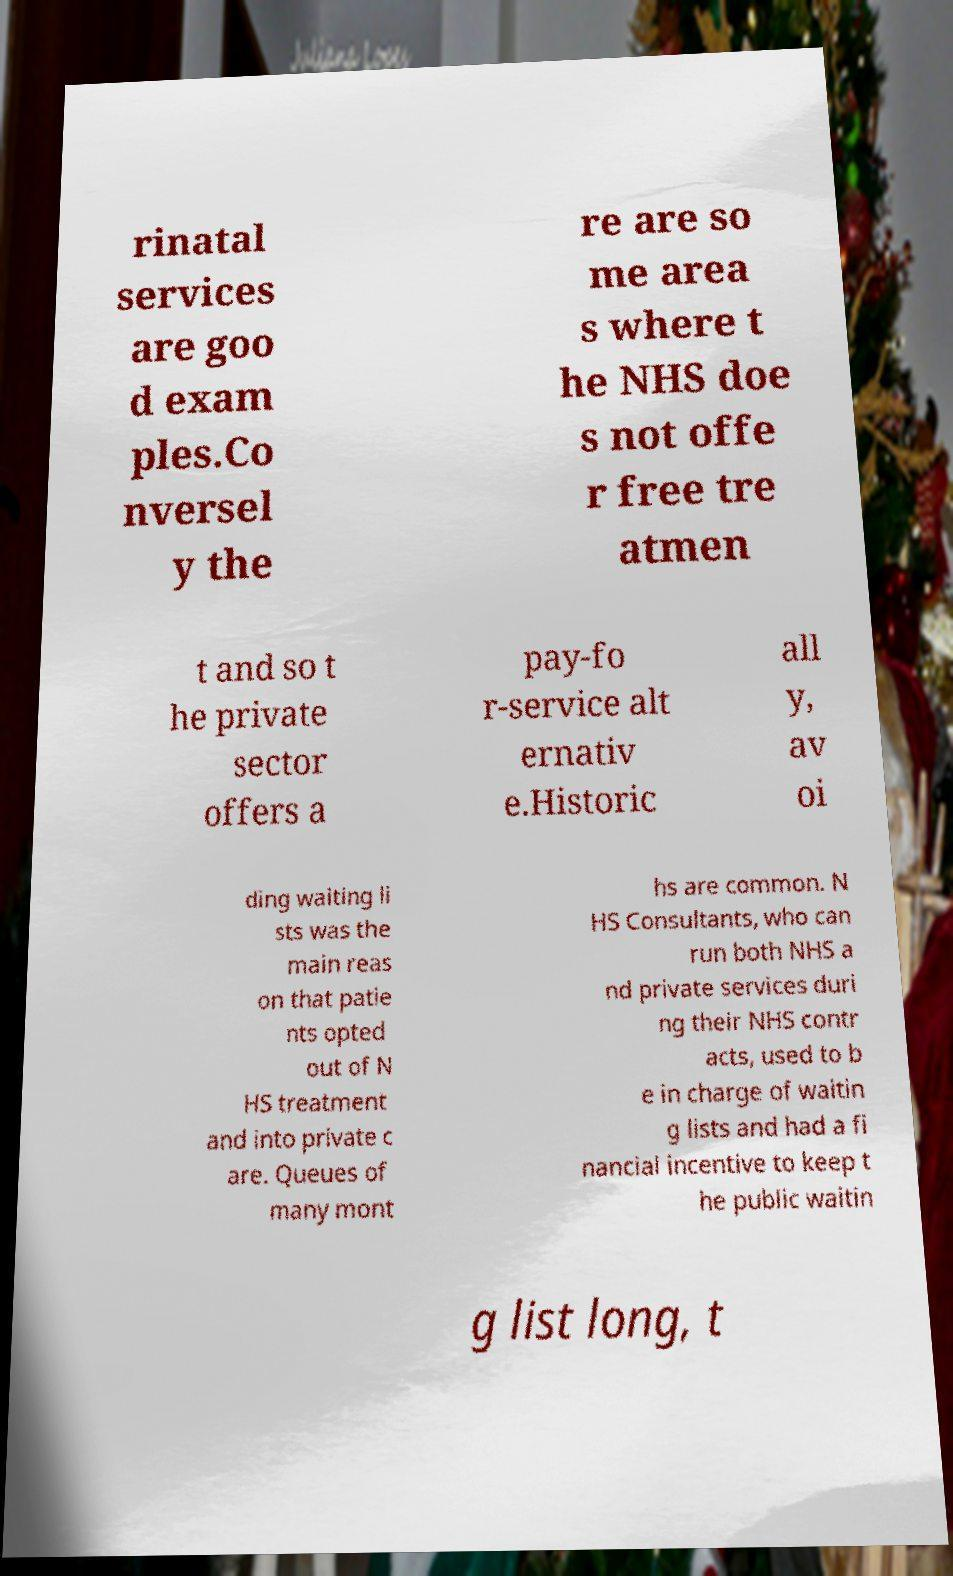For documentation purposes, I need the text within this image transcribed. Could you provide that? rinatal services are goo d exam ples.Co nversel y the re are so me area s where t he NHS doe s not offe r free tre atmen t and so t he private sector offers a pay-fo r-service alt ernativ e.Historic all y, av oi ding waiting li sts was the main reas on that patie nts opted out of N HS treatment and into private c are. Queues of many mont hs are common. N HS Consultants, who can run both NHS a nd private services duri ng their NHS contr acts, used to b e in charge of waitin g lists and had a fi nancial incentive to keep t he public waitin g list long, t 